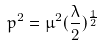Convert formula to latex. <formula><loc_0><loc_0><loc_500><loc_500>p ^ { 2 } = \mu ^ { 2 } ( \frac { \lambda } { 2 } ) ^ { \frac { 1 } { 2 } }</formula> 